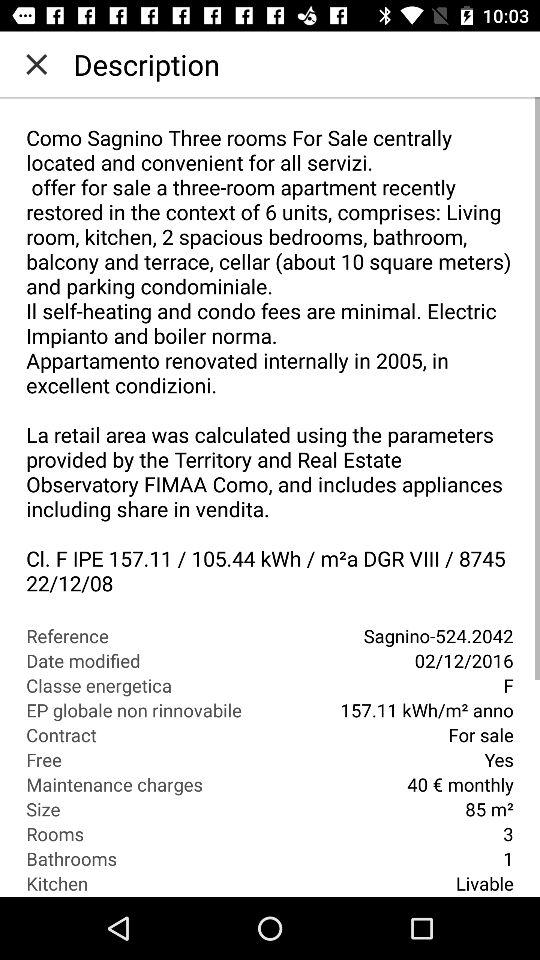What is the date of modification? The date of modification is December 2, 2016. 